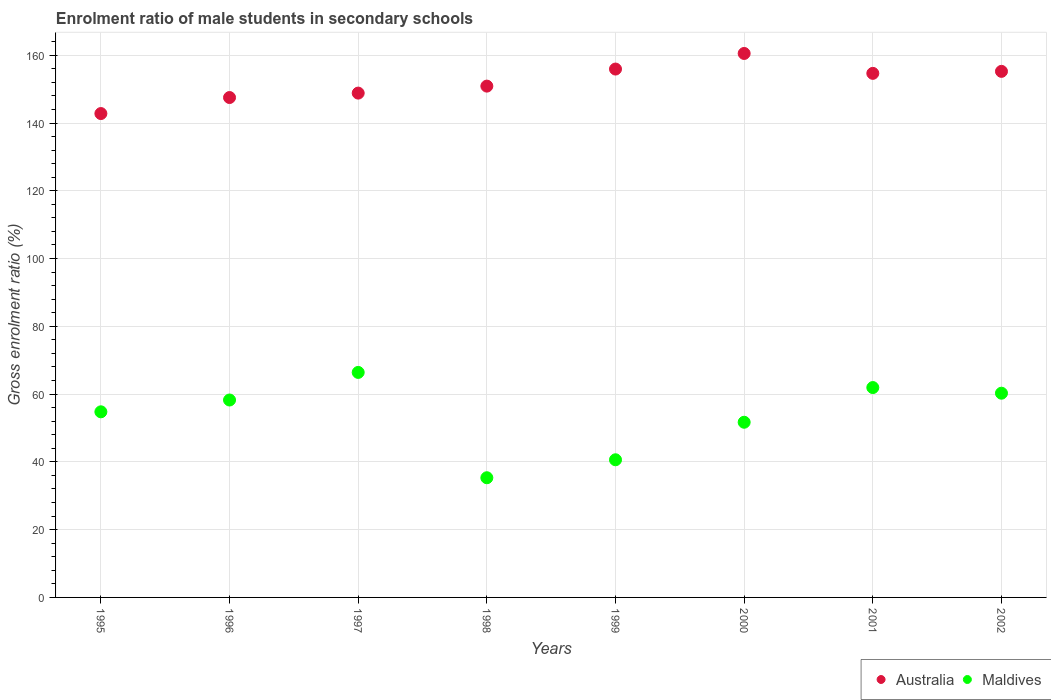Is the number of dotlines equal to the number of legend labels?
Offer a very short reply. Yes. What is the enrolment ratio of male students in secondary schools in Australia in 1997?
Give a very brief answer. 148.82. Across all years, what is the maximum enrolment ratio of male students in secondary schools in Australia?
Offer a terse response. 160.52. Across all years, what is the minimum enrolment ratio of male students in secondary schools in Australia?
Your response must be concise. 142.79. In which year was the enrolment ratio of male students in secondary schools in Maldives minimum?
Provide a succinct answer. 1998. What is the total enrolment ratio of male students in secondary schools in Maldives in the graph?
Your response must be concise. 429.25. What is the difference between the enrolment ratio of male students in secondary schools in Maldives in 1996 and that in 2002?
Your response must be concise. -2.01. What is the difference between the enrolment ratio of male students in secondary schools in Australia in 1998 and the enrolment ratio of male students in secondary schools in Maldives in 1999?
Offer a very short reply. 110.27. What is the average enrolment ratio of male students in secondary schools in Maldives per year?
Provide a short and direct response. 53.66. In the year 2000, what is the difference between the enrolment ratio of male students in secondary schools in Australia and enrolment ratio of male students in secondary schools in Maldives?
Your answer should be compact. 108.83. In how many years, is the enrolment ratio of male students in secondary schools in Australia greater than 156 %?
Give a very brief answer. 1. What is the ratio of the enrolment ratio of male students in secondary schools in Australia in 1995 to that in 2002?
Ensure brevity in your answer.  0.92. Is the enrolment ratio of male students in secondary schools in Australia in 1995 less than that in 1996?
Give a very brief answer. Yes. What is the difference between the highest and the second highest enrolment ratio of male students in secondary schools in Australia?
Your answer should be very brief. 4.6. What is the difference between the highest and the lowest enrolment ratio of male students in secondary schools in Maldives?
Offer a very short reply. 31.08. In how many years, is the enrolment ratio of male students in secondary schools in Maldives greater than the average enrolment ratio of male students in secondary schools in Maldives taken over all years?
Your response must be concise. 5. Is the enrolment ratio of male students in secondary schools in Australia strictly less than the enrolment ratio of male students in secondary schools in Maldives over the years?
Make the answer very short. No. How many dotlines are there?
Your response must be concise. 2. How many years are there in the graph?
Your response must be concise. 8. What is the difference between two consecutive major ticks on the Y-axis?
Your answer should be compact. 20. Are the values on the major ticks of Y-axis written in scientific E-notation?
Offer a very short reply. No. Does the graph contain any zero values?
Provide a short and direct response. No. Does the graph contain grids?
Provide a short and direct response. Yes. What is the title of the graph?
Make the answer very short. Enrolment ratio of male students in secondary schools. Does "Middle East & North Africa (all income levels)" appear as one of the legend labels in the graph?
Ensure brevity in your answer.  No. What is the label or title of the X-axis?
Offer a very short reply. Years. What is the Gross enrolment ratio (%) of Australia in 1995?
Offer a very short reply. 142.79. What is the Gross enrolment ratio (%) of Maldives in 1995?
Keep it short and to the point. 54.77. What is the Gross enrolment ratio (%) in Australia in 1996?
Make the answer very short. 147.52. What is the Gross enrolment ratio (%) of Maldives in 1996?
Your answer should be very brief. 58.26. What is the Gross enrolment ratio (%) in Australia in 1997?
Ensure brevity in your answer.  148.82. What is the Gross enrolment ratio (%) of Maldives in 1997?
Provide a short and direct response. 66.4. What is the Gross enrolment ratio (%) of Australia in 1998?
Your response must be concise. 150.89. What is the Gross enrolment ratio (%) of Maldives in 1998?
Ensure brevity in your answer.  35.32. What is the Gross enrolment ratio (%) in Australia in 1999?
Offer a very short reply. 155.92. What is the Gross enrolment ratio (%) of Maldives in 1999?
Ensure brevity in your answer.  40.62. What is the Gross enrolment ratio (%) in Australia in 2000?
Keep it short and to the point. 160.52. What is the Gross enrolment ratio (%) of Maldives in 2000?
Ensure brevity in your answer.  51.69. What is the Gross enrolment ratio (%) of Australia in 2001?
Offer a terse response. 154.65. What is the Gross enrolment ratio (%) in Maldives in 2001?
Offer a terse response. 61.93. What is the Gross enrolment ratio (%) in Australia in 2002?
Keep it short and to the point. 155.24. What is the Gross enrolment ratio (%) of Maldives in 2002?
Give a very brief answer. 60.27. Across all years, what is the maximum Gross enrolment ratio (%) of Australia?
Provide a succinct answer. 160.52. Across all years, what is the maximum Gross enrolment ratio (%) in Maldives?
Offer a very short reply. 66.4. Across all years, what is the minimum Gross enrolment ratio (%) of Australia?
Give a very brief answer. 142.79. Across all years, what is the minimum Gross enrolment ratio (%) in Maldives?
Your answer should be very brief. 35.32. What is the total Gross enrolment ratio (%) of Australia in the graph?
Ensure brevity in your answer.  1216.34. What is the total Gross enrolment ratio (%) of Maldives in the graph?
Offer a very short reply. 429.25. What is the difference between the Gross enrolment ratio (%) of Australia in 1995 and that in 1996?
Offer a terse response. -4.73. What is the difference between the Gross enrolment ratio (%) of Maldives in 1995 and that in 1996?
Offer a terse response. -3.49. What is the difference between the Gross enrolment ratio (%) of Australia in 1995 and that in 1997?
Make the answer very short. -6.03. What is the difference between the Gross enrolment ratio (%) of Maldives in 1995 and that in 1997?
Make the answer very short. -11.63. What is the difference between the Gross enrolment ratio (%) in Australia in 1995 and that in 1998?
Provide a succinct answer. -8.1. What is the difference between the Gross enrolment ratio (%) of Maldives in 1995 and that in 1998?
Provide a succinct answer. 19.45. What is the difference between the Gross enrolment ratio (%) in Australia in 1995 and that in 1999?
Keep it short and to the point. -13.13. What is the difference between the Gross enrolment ratio (%) in Maldives in 1995 and that in 1999?
Your answer should be compact. 14.15. What is the difference between the Gross enrolment ratio (%) of Australia in 1995 and that in 2000?
Provide a short and direct response. -17.73. What is the difference between the Gross enrolment ratio (%) of Maldives in 1995 and that in 2000?
Ensure brevity in your answer.  3.08. What is the difference between the Gross enrolment ratio (%) in Australia in 1995 and that in 2001?
Keep it short and to the point. -11.86. What is the difference between the Gross enrolment ratio (%) of Maldives in 1995 and that in 2001?
Offer a very short reply. -7.16. What is the difference between the Gross enrolment ratio (%) in Australia in 1995 and that in 2002?
Offer a very short reply. -12.45. What is the difference between the Gross enrolment ratio (%) in Maldives in 1995 and that in 2002?
Offer a terse response. -5.49. What is the difference between the Gross enrolment ratio (%) of Australia in 1996 and that in 1997?
Keep it short and to the point. -1.31. What is the difference between the Gross enrolment ratio (%) of Maldives in 1996 and that in 1997?
Offer a very short reply. -8.14. What is the difference between the Gross enrolment ratio (%) of Australia in 1996 and that in 1998?
Ensure brevity in your answer.  -3.37. What is the difference between the Gross enrolment ratio (%) in Maldives in 1996 and that in 1998?
Your answer should be compact. 22.94. What is the difference between the Gross enrolment ratio (%) in Australia in 1996 and that in 1999?
Ensure brevity in your answer.  -8.4. What is the difference between the Gross enrolment ratio (%) of Maldives in 1996 and that in 1999?
Offer a very short reply. 17.64. What is the difference between the Gross enrolment ratio (%) in Australia in 1996 and that in 2000?
Your answer should be compact. -13. What is the difference between the Gross enrolment ratio (%) in Maldives in 1996 and that in 2000?
Offer a very short reply. 6.56. What is the difference between the Gross enrolment ratio (%) of Australia in 1996 and that in 2001?
Offer a terse response. -7.13. What is the difference between the Gross enrolment ratio (%) in Maldives in 1996 and that in 2001?
Your response must be concise. -3.67. What is the difference between the Gross enrolment ratio (%) in Australia in 1996 and that in 2002?
Give a very brief answer. -7.72. What is the difference between the Gross enrolment ratio (%) in Maldives in 1996 and that in 2002?
Your response must be concise. -2.01. What is the difference between the Gross enrolment ratio (%) of Australia in 1997 and that in 1998?
Keep it short and to the point. -2.06. What is the difference between the Gross enrolment ratio (%) of Maldives in 1997 and that in 1998?
Offer a very short reply. 31.08. What is the difference between the Gross enrolment ratio (%) of Australia in 1997 and that in 1999?
Provide a succinct answer. -7.1. What is the difference between the Gross enrolment ratio (%) of Maldives in 1997 and that in 1999?
Offer a terse response. 25.78. What is the difference between the Gross enrolment ratio (%) in Australia in 1997 and that in 2000?
Make the answer very short. -11.7. What is the difference between the Gross enrolment ratio (%) in Maldives in 1997 and that in 2000?
Keep it short and to the point. 14.7. What is the difference between the Gross enrolment ratio (%) in Australia in 1997 and that in 2001?
Your response must be concise. -5.83. What is the difference between the Gross enrolment ratio (%) of Maldives in 1997 and that in 2001?
Your response must be concise. 4.47. What is the difference between the Gross enrolment ratio (%) of Australia in 1997 and that in 2002?
Make the answer very short. -6.42. What is the difference between the Gross enrolment ratio (%) of Maldives in 1997 and that in 2002?
Provide a short and direct response. 6.13. What is the difference between the Gross enrolment ratio (%) in Australia in 1998 and that in 1999?
Your answer should be compact. -5.03. What is the difference between the Gross enrolment ratio (%) of Maldives in 1998 and that in 1999?
Your answer should be compact. -5.3. What is the difference between the Gross enrolment ratio (%) in Australia in 1998 and that in 2000?
Make the answer very short. -9.63. What is the difference between the Gross enrolment ratio (%) of Maldives in 1998 and that in 2000?
Your answer should be compact. -16.38. What is the difference between the Gross enrolment ratio (%) of Australia in 1998 and that in 2001?
Offer a terse response. -3.76. What is the difference between the Gross enrolment ratio (%) of Maldives in 1998 and that in 2001?
Make the answer very short. -26.61. What is the difference between the Gross enrolment ratio (%) in Australia in 1998 and that in 2002?
Keep it short and to the point. -4.35. What is the difference between the Gross enrolment ratio (%) in Maldives in 1998 and that in 2002?
Your answer should be very brief. -24.95. What is the difference between the Gross enrolment ratio (%) in Australia in 1999 and that in 2000?
Make the answer very short. -4.6. What is the difference between the Gross enrolment ratio (%) of Maldives in 1999 and that in 2000?
Offer a terse response. -11.07. What is the difference between the Gross enrolment ratio (%) of Australia in 1999 and that in 2001?
Your answer should be very brief. 1.27. What is the difference between the Gross enrolment ratio (%) of Maldives in 1999 and that in 2001?
Make the answer very short. -21.31. What is the difference between the Gross enrolment ratio (%) of Australia in 1999 and that in 2002?
Provide a succinct answer. 0.68. What is the difference between the Gross enrolment ratio (%) in Maldives in 1999 and that in 2002?
Keep it short and to the point. -19.65. What is the difference between the Gross enrolment ratio (%) in Australia in 2000 and that in 2001?
Keep it short and to the point. 5.87. What is the difference between the Gross enrolment ratio (%) in Maldives in 2000 and that in 2001?
Offer a very short reply. -10.24. What is the difference between the Gross enrolment ratio (%) of Australia in 2000 and that in 2002?
Make the answer very short. 5.28. What is the difference between the Gross enrolment ratio (%) of Maldives in 2000 and that in 2002?
Keep it short and to the point. -8.57. What is the difference between the Gross enrolment ratio (%) in Australia in 2001 and that in 2002?
Keep it short and to the point. -0.59. What is the difference between the Gross enrolment ratio (%) in Maldives in 2001 and that in 2002?
Your answer should be compact. 1.67. What is the difference between the Gross enrolment ratio (%) of Australia in 1995 and the Gross enrolment ratio (%) of Maldives in 1996?
Make the answer very short. 84.53. What is the difference between the Gross enrolment ratio (%) of Australia in 1995 and the Gross enrolment ratio (%) of Maldives in 1997?
Your answer should be compact. 76.39. What is the difference between the Gross enrolment ratio (%) of Australia in 1995 and the Gross enrolment ratio (%) of Maldives in 1998?
Ensure brevity in your answer.  107.47. What is the difference between the Gross enrolment ratio (%) in Australia in 1995 and the Gross enrolment ratio (%) in Maldives in 1999?
Provide a short and direct response. 102.17. What is the difference between the Gross enrolment ratio (%) in Australia in 1995 and the Gross enrolment ratio (%) in Maldives in 2000?
Offer a terse response. 91.09. What is the difference between the Gross enrolment ratio (%) of Australia in 1995 and the Gross enrolment ratio (%) of Maldives in 2001?
Your answer should be compact. 80.86. What is the difference between the Gross enrolment ratio (%) in Australia in 1995 and the Gross enrolment ratio (%) in Maldives in 2002?
Provide a short and direct response. 82.52. What is the difference between the Gross enrolment ratio (%) in Australia in 1996 and the Gross enrolment ratio (%) in Maldives in 1997?
Ensure brevity in your answer.  81.12. What is the difference between the Gross enrolment ratio (%) of Australia in 1996 and the Gross enrolment ratio (%) of Maldives in 1998?
Offer a terse response. 112.2. What is the difference between the Gross enrolment ratio (%) in Australia in 1996 and the Gross enrolment ratio (%) in Maldives in 1999?
Offer a terse response. 106.9. What is the difference between the Gross enrolment ratio (%) of Australia in 1996 and the Gross enrolment ratio (%) of Maldives in 2000?
Offer a terse response. 95.82. What is the difference between the Gross enrolment ratio (%) of Australia in 1996 and the Gross enrolment ratio (%) of Maldives in 2001?
Provide a succinct answer. 85.58. What is the difference between the Gross enrolment ratio (%) of Australia in 1996 and the Gross enrolment ratio (%) of Maldives in 2002?
Make the answer very short. 87.25. What is the difference between the Gross enrolment ratio (%) of Australia in 1997 and the Gross enrolment ratio (%) of Maldives in 1998?
Keep it short and to the point. 113.5. What is the difference between the Gross enrolment ratio (%) in Australia in 1997 and the Gross enrolment ratio (%) in Maldives in 1999?
Make the answer very short. 108.2. What is the difference between the Gross enrolment ratio (%) in Australia in 1997 and the Gross enrolment ratio (%) in Maldives in 2000?
Offer a very short reply. 97.13. What is the difference between the Gross enrolment ratio (%) of Australia in 1997 and the Gross enrolment ratio (%) of Maldives in 2001?
Offer a terse response. 86.89. What is the difference between the Gross enrolment ratio (%) of Australia in 1997 and the Gross enrolment ratio (%) of Maldives in 2002?
Provide a short and direct response. 88.56. What is the difference between the Gross enrolment ratio (%) in Australia in 1998 and the Gross enrolment ratio (%) in Maldives in 1999?
Make the answer very short. 110.27. What is the difference between the Gross enrolment ratio (%) of Australia in 1998 and the Gross enrolment ratio (%) of Maldives in 2000?
Ensure brevity in your answer.  99.19. What is the difference between the Gross enrolment ratio (%) of Australia in 1998 and the Gross enrolment ratio (%) of Maldives in 2001?
Your answer should be very brief. 88.95. What is the difference between the Gross enrolment ratio (%) of Australia in 1998 and the Gross enrolment ratio (%) of Maldives in 2002?
Make the answer very short. 90.62. What is the difference between the Gross enrolment ratio (%) in Australia in 1999 and the Gross enrolment ratio (%) in Maldives in 2000?
Offer a very short reply. 104.23. What is the difference between the Gross enrolment ratio (%) in Australia in 1999 and the Gross enrolment ratio (%) in Maldives in 2001?
Offer a very short reply. 93.99. What is the difference between the Gross enrolment ratio (%) in Australia in 1999 and the Gross enrolment ratio (%) in Maldives in 2002?
Keep it short and to the point. 95.65. What is the difference between the Gross enrolment ratio (%) in Australia in 2000 and the Gross enrolment ratio (%) in Maldives in 2001?
Provide a short and direct response. 98.59. What is the difference between the Gross enrolment ratio (%) in Australia in 2000 and the Gross enrolment ratio (%) in Maldives in 2002?
Make the answer very short. 100.25. What is the difference between the Gross enrolment ratio (%) of Australia in 2001 and the Gross enrolment ratio (%) of Maldives in 2002?
Make the answer very short. 94.38. What is the average Gross enrolment ratio (%) in Australia per year?
Ensure brevity in your answer.  152.04. What is the average Gross enrolment ratio (%) of Maldives per year?
Offer a terse response. 53.66. In the year 1995, what is the difference between the Gross enrolment ratio (%) of Australia and Gross enrolment ratio (%) of Maldives?
Provide a short and direct response. 88.02. In the year 1996, what is the difference between the Gross enrolment ratio (%) of Australia and Gross enrolment ratio (%) of Maldives?
Your answer should be very brief. 89.26. In the year 1997, what is the difference between the Gross enrolment ratio (%) of Australia and Gross enrolment ratio (%) of Maldives?
Provide a short and direct response. 82.42. In the year 1998, what is the difference between the Gross enrolment ratio (%) in Australia and Gross enrolment ratio (%) in Maldives?
Keep it short and to the point. 115.57. In the year 1999, what is the difference between the Gross enrolment ratio (%) in Australia and Gross enrolment ratio (%) in Maldives?
Offer a very short reply. 115.3. In the year 2000, what is the difference between the Gross enrolment ratio (%) in Australia and Gross enrolment ratio (%) in Maldives?
Offer a very short reply. 108.83. In the year 2001, what is the difference between the Gross enrolment ratio (%) of Australia and Gross enrolment ratio (%) of Maldives?
Your response must be concise. 92.72. In the year 2002, what is the difference between the Gross enrolment ratio (%) in Australia and Gross enrolment ratio (%) in Maldives?
Keep it short and to the point. 94.97. What is the ratio of the Gross enrolment ratio (%) of Australia in 1995 to that in 1996?
Your answer should be compact. 0.97. What is the ratio of the Gross enrolment ratio (%) of Maldives in 1995 to that in 1996?
Offer a very short reply. 0.94. What is the ratio of the Gross enrolment ratio (%) of Australia in 1995 to that in 1997?
Offer a very short reply. 0.96. What is the ratio of the Gross enrolment ratio (%) of Maldives in 1995 to that in 1997?
Your answer should be very brief. 0.82. What is the ratio of the Gross enrolment ratio (%) of Australia in 1995 to that in 1998?
Offer a very short reply. 0.95. What is the ratio of the Gross enrolment ratio (%) of Maldives in 1995 to that in 1998?
Give a very brief answer. 1.55. What is the ratio of the Gross enrolment ratio (%) in Australia in 1995 to that in 1999?
Your answer should be compact. 0.92. What is the ratio of the Gross enrolment ratio (%) of Maldives in 1995 to that in 1999?
Make the answer very short. 1.35. What is the ratio of the Gross enrolment ratio (%) in Australia in 1995 to that in 2000?
Your response must be concise. 0.89. What is the ratio of the Gross enrolment ratio (%) of Maldives in 1995 to that in 2000?
Your response must be concise. 1.06. What is the ratio of the Gross enrolment ratio (%) of Australia in 1995 to that in 2001?
Offer a very short reply. 0.92. What is the ratio of the Gross enrolment ratio (%) in Maldives in 1995 to that in 2001?
Keep it short and to the point. 0.88. What is the ratio of the Gross enrolment ratio (%) in Australia in 1995 to that in 2002?
Your response must be concise. 0.92. What is the ratio of the Gross enrolment ratio (%) in Maldives in 1995 to that in 2002?
Your answer should be very brief. 0.91. What is the ratio of the Gross enrolment ratio (%) of Maldives in 1996 to that in 1997?
Offer a terse response. 0.88. What is the ratio of the Gross enrolment ratio (%) of Australia in 1996 to that in 1998?
Provide a succinct answer. 0.98. What is the ratio of the Gross enrolment ratio (%) of Maldives in 1996 to that in 1998?
Your answer should be very brief. 1.65. What is the ratio of the Gross enrolment ratio (%) of Australia in 1996 to that in 1999?
Give a very brief answer. 0.95. What is the ratio of the Gross enrolment ratio (%) of Maldives in 1996 to that in 1999?
Your answer should be compact. 1.43. What is the ratio of the Gross enrolment ratio (%) of Australia in 1996 to that in 2000?
Make the answer very short. 0.92. What is the ratio of the Gross enrolment ratio (%) of Maldives in 1996 to that in 2000?
Offer a very short reply. 1.13. What is the ratio of the Gross enrolment ratio (%) of Australia in 1996 to that in 2001?
Your response must be concise. 0.95. What is the ratio of the Gross enrolment ratio (%) in Maldives in 1996 to that in 2001?
Make the answer very short. 0.94. What is the ratio of the Gross enrolment ratio (%) in Australia in 1996 to that in 2002?
Your answer should be very brief. 0.95. What is the ratio of the Gross enrolment ratio (%) of Maldives in 1996 to that in 2002?
Your answer should be compact. 0.97. What is the ratio of the Gross enrolment ratio (%) of Australia in 1997 to that in 1998?
Provide a succinct answer. 0.99. What is the ratio of the Gross enrolment ratio (%) in Maldives in 1997 to that in 1998?
Your answer should be very brief. 1.88. What is the ratio of the Gross enrolment ratio (%) of Australia in 1997 to that in 1999?
Ensure brevity in your answer.  0.95. What is the ratio of the Gross enrolment ratio (%) of Maldives in 1997 to that in 1999?
Your answer should be very brief. 1.63. What is the ratio of the Gross enrolment ratio (%) in Australia in 1997 to that in 2000?
Provide a succinct answer. 0.93. What is the ratio of the Gross enrolment ratio (%) in Maldives in 1997 to that in 2000?
Provide a succinct answer. 1.28. What is the ratio of the Gross enrolment ratio (%) in Australia in 1997 to that in 2001?
Offer a terse response. 0.96. What is the ratio of the Gross enrolment ratio (%) of Maldives in 1997 to that in 2001?
Your answer should be very brief. 1.07. What is the ratio of the Gross enrolment ratio (%) of Australia in 1997 to that in 2002?
Offer a terse response. 0.96. What is the ratio of the Gross enrolment ratio (%) in Maldives in 1997 to that in 2002?
Provide a succinct answer. 1.1. What is the ratio of the Gross enrolment ratio (%) of Maldives in 1998 to that in 1999?
Your answer should be very brief. 0.87. What is the ratio of the Gross enrolment ratio (%) in Maldives in 1998 to that in 2000?
Ensure brevity in your answer.  0.68. What is the ratio of the Gross enrolment ratio (%) of Australia in 1998 to that in 2001?
Give a very brief answer. 0.98. What is the ratio of the Gross enrolment ratio (%) of Maldives in 1998 to that in 2001?
Your answer should be compact. 0.57. What is the ratio of the Gross enrolment ratio (%) in Maldives in 1998 to that in 2002?
Make the answer very short. 0.59. What is the ratio of the Gross enrolment ratio (%) of Australia in 1999 to that in 2000?
Your answer should be very brief. 0.97. What is the ratio of the Gross enrolment ratio (%) in Maldives in 1999 to that in 2000?
Offer a very short reply. 0.79. What is the ratio of the Gross enrolment ratio (%) in Australia in 1999 to that in 2001?
Your answer should be very brief. 1.01. What is the ratio of the Gross enrolment ratio (%) in Maldives in 1999 to that in 2001?
Make the answer very short. 0.66. What is the ratio of the Gross enrolment ratio (%) of Maldives in 1999 to that in 2002?
Offer a terse response. 0.67. What is the ratio of the Gross enrolment ratio (%) of Australia in 2000 to that in 2001?
Provide a short and direct response. 1.04. What is the ratio of the Gross enrolment ratio (%) of Maldives in 2000 to that in 2001?
Keep it short and to the point. 0.83. What is the ratio of the Gross enrolment ratio (%) in Australia in 2000 to that in 2002?
Your answer should be very brief. 1.03. What is the ratio of the Gross enrolment ratio (%) in Maldives in 2000 to that in 2002?
Your answer should be very brief. 0.86. What is the ratio of the Gross enrolment ratio (%) of Maldives in 2001 to that in 2002?
Keep it short and to the point. 1.03. What is the difference between the highest and the second highest Gross enrolment ratio (%) in Australia?
Offer a terse response. 4.6. What is the difference between the highest and the second highest Gross enrolment ratio (%) of Maldives?
Your response must be concise. 4.47. What is the difference between the highest and the lowest Gross enrolment ratio (%) of Australia?
Provide a succinct answer. 17.73. What is the difference between the highest and the lowest Gross enrolment ratio (%) of Maldives?
Your answer should be compact. 31.08. 